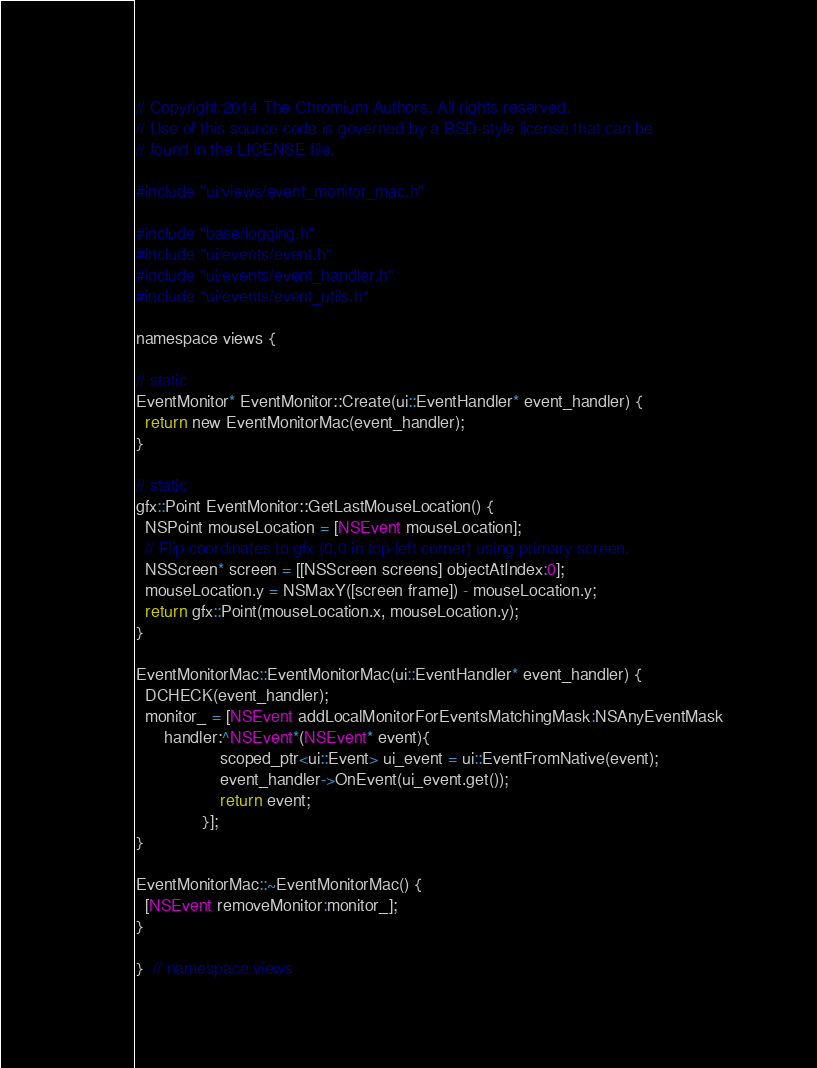<code> <loc_0><loc_0><loc_500><loc_500><_ObjectiveC_>// Copyright 2014 The Chromium Authors. All rights reserved.
// Use of this source code is governed by a BSD-style license that can be
// found in the LICENSE file.

#include "ui/views/event_monitor_mac.h"

#include "base/logging.h"
#include "ui/events/event.h"
#include "ui/events/event_handler.h"
#include "ui/events/event_utils.h"

namespace views {

// static
EventMonitor* EventMonitor::Create(ui::EventHandler* event_handler) {
  return new EventMonitorMac(event_handler);
}

// static
gfx::Point EventMonitor::GetLastMouseLocation() {
  NSPoint mouseLocation = [NSEvent mouseLocation];
  // Flip coordinates to gfx (0,0 in top-left corner) using primary screen.
  NSScreen* screen = [[NSScreen screens] objectAtIndex:0];
  mouseLocation.y = NSMaxY([screen frame]) - mouseLocation.y;
  return gfx::Point(mouseLocation.x, mouseLocation.y);
}

EventMonitorMac::EventMonitorMac(ui::EventHandler* event_handler) {
  DCHECK(event_handler);
  monitor_ = [NSEvent addLocalMonitorForEventsMatchingMask:NSAnyEventMask
      handler:^NSEvent*(NSEvent* event){
                  scoped_ptr<ui::Event> ui_event = ui::EventFromNative(event);
                  event_handler->OnEvent(ui_event.get());
                  return event;
              }];
}

EventMonitorMac::~EventMonitorMac() {
  [NSEvent removeMonitor:monitor_];
}

}  // namespace views
</code> 